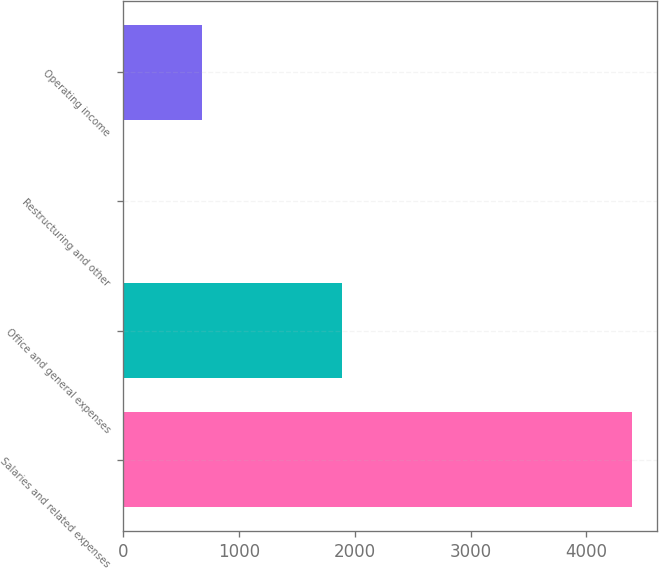<chart> <loc_0><loc_0><loc_500><loc_500><bar_chart><fcel>Salaries and related expenses<fcel>Office and general expenses<fcel>Restructuring and other<fcel>Operating income<nl><fcel>4391.9<fcel>1887.2<fcel>1.2<fcel>678.3<nl></chart> 